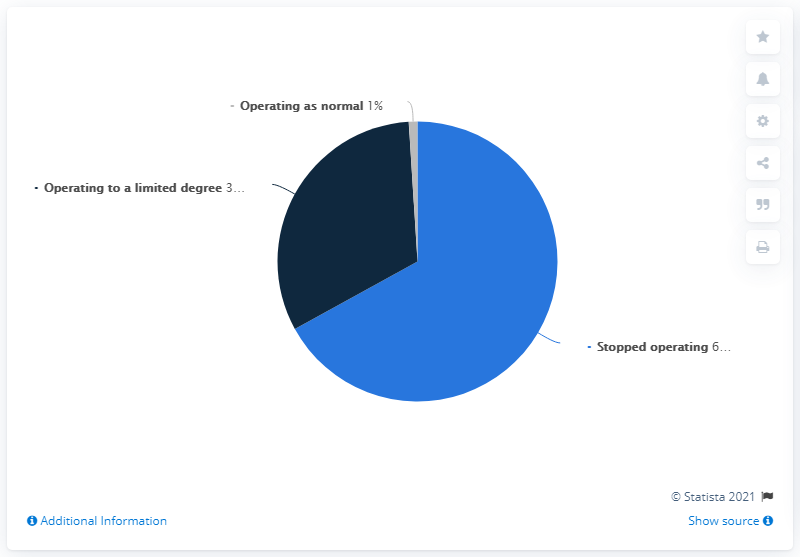Highlight a few significant elements in this photo. Gray is the color that has the least value. The dominant segment is colored light blue. 